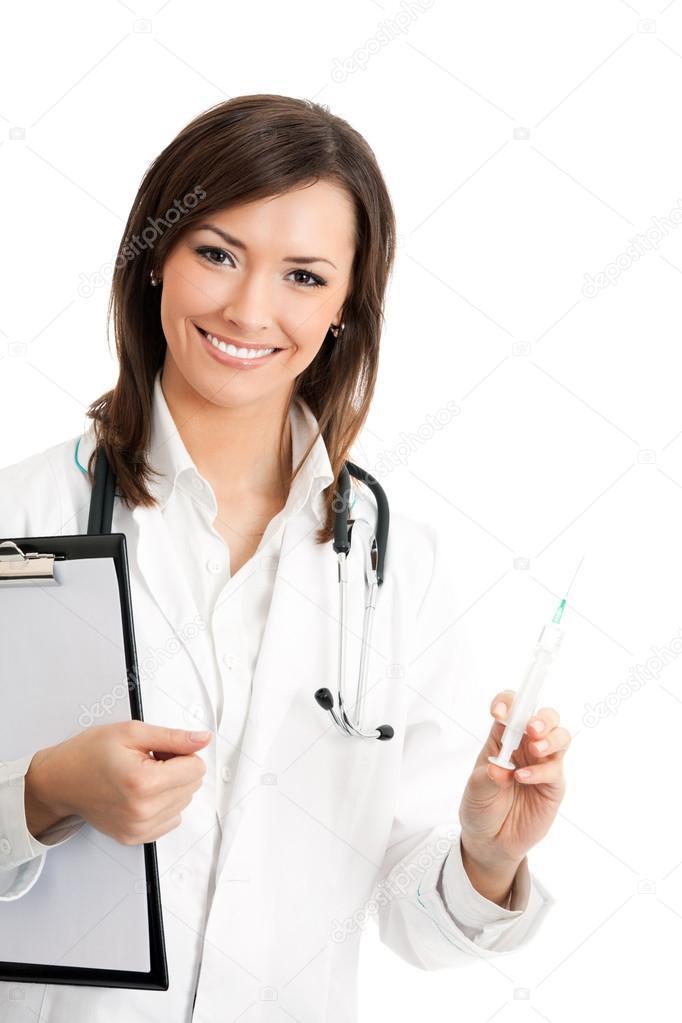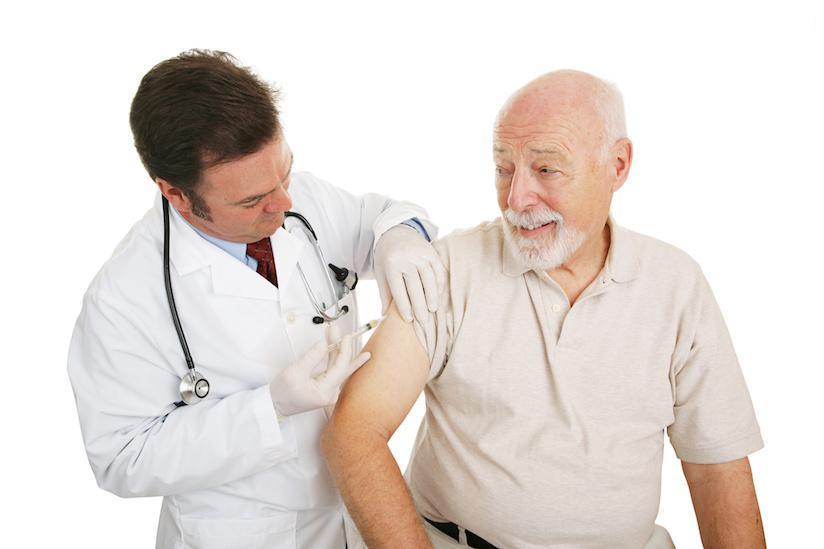The first image is the image on the left, the second image is the image on the right. For the images shown, is this caption "There are two women holding needles." true? Answer yes or no. No. The first image is the image on the left, the second image is the image on the right. Given the left and right images, does the statement "Two women are holding syringes." hold true? Answer yes or no. No. 